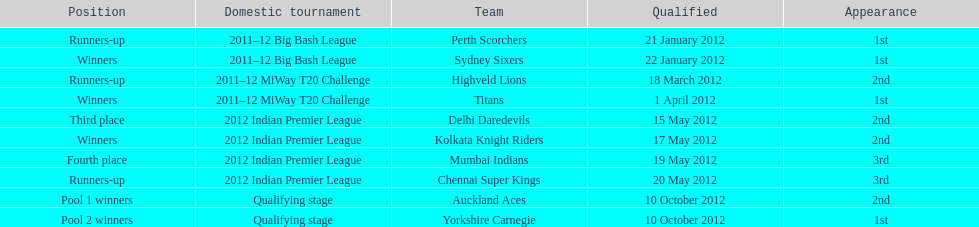Which team made their first appearance in the same tournament as the perth scorchers? Sydney Sixers. 